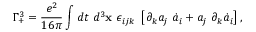<formula> <loc_0><loc_0><loc_500><loc_500>\Gamma _ { + } ^ { 3 } = \frac { e ^ { 2 } } { 1 6 \pi } \int d t d ^ { 3 } { x } \epsilon _ { i j k } \left [ \partial _ { k } a _ { j } \dot { a } _ { i } + a _ { j } \partial _ { k } \dot { a } _ { i } \right ] ,</formula> 